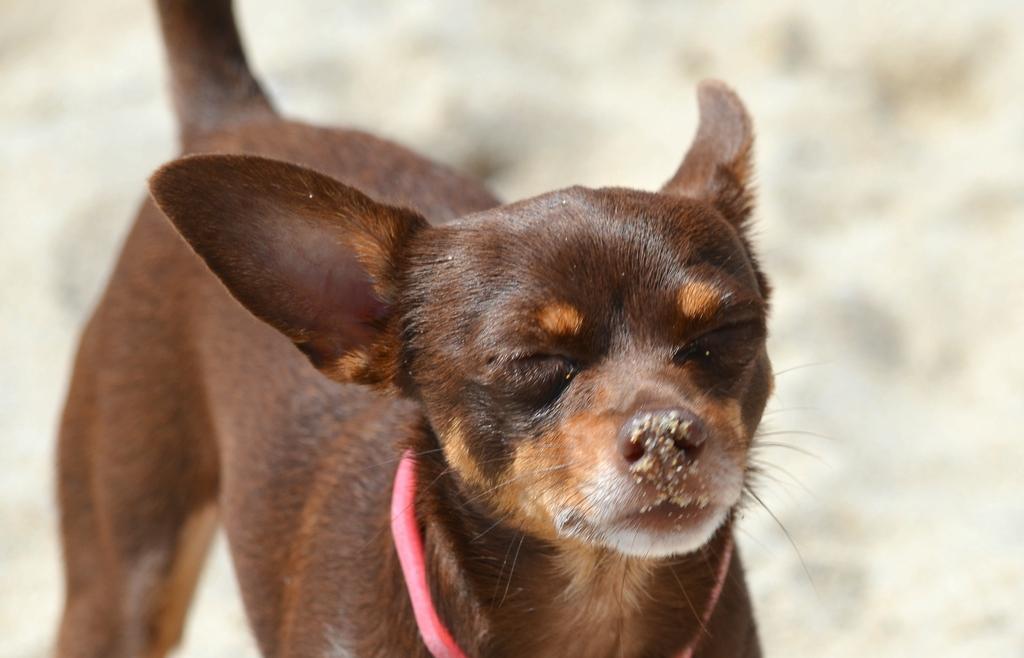Can you describe this image briefly? In this image there is a dog standing on the ground. There is a belt around its neck. There is the sand on its nose. Behind it, it is blurry. 